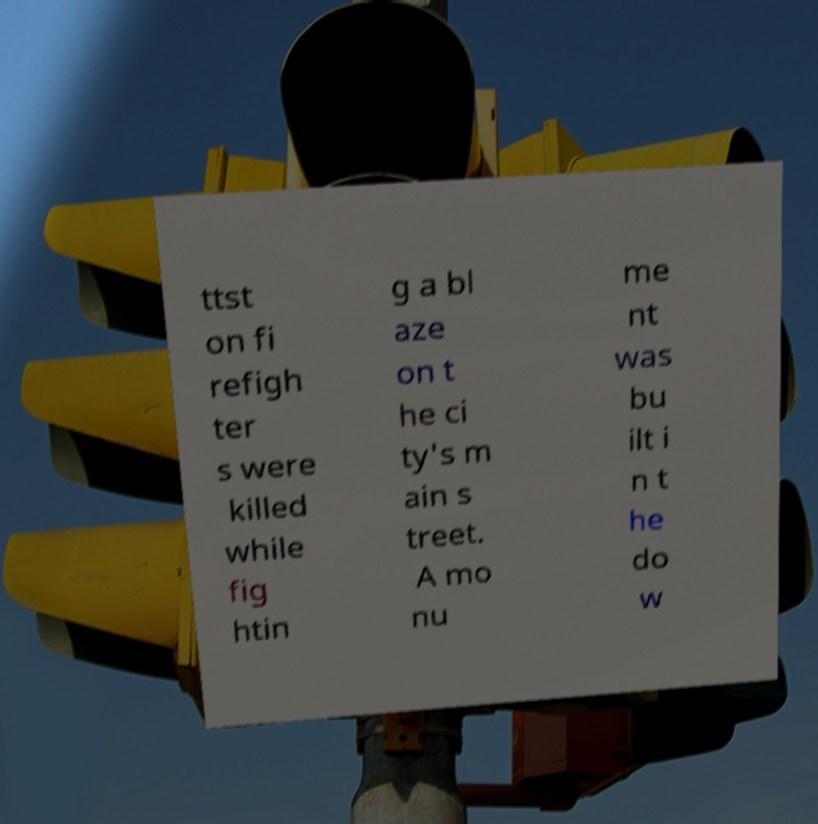Could you extract and type out the text from this image? ttst on fi refigh ter s were killed while fig htin g a bl aze on t he ci ty's m ain s treet. A mo nu me nt was bu ilt i n t he do w 